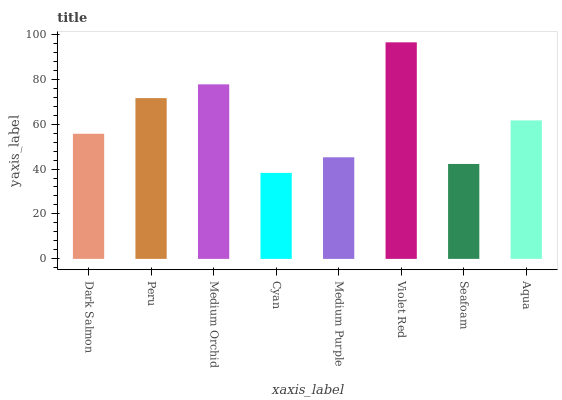Is Cyan the minimum?
Answer yes or no. Yes. Is Violet Red the maximum?
Answer yes or no. Yes. Is Peru the minimum?
Answer yes or no. No. Is Peru the maximum?
Answer yes or no. No. Is Peru greater than Dark Salmon?
Answer yes or no. Yes. Is Dark Salmon less than Peru?
Answer yes or no. Yes. Is Dark Salmon greater than Peru?
Answer yes or no. No. Is Peru less than Dark Salmon?
Answer yes or no. No. Is Aqua the high median?
Answer yes or no. Yes. Is Dark Salmon the low median?
Answer yes or no. Yes. Is Dark Salmon the high median?
Answer yes or no. No. Is Violet Red the low median?
Answer yes or no. No. 